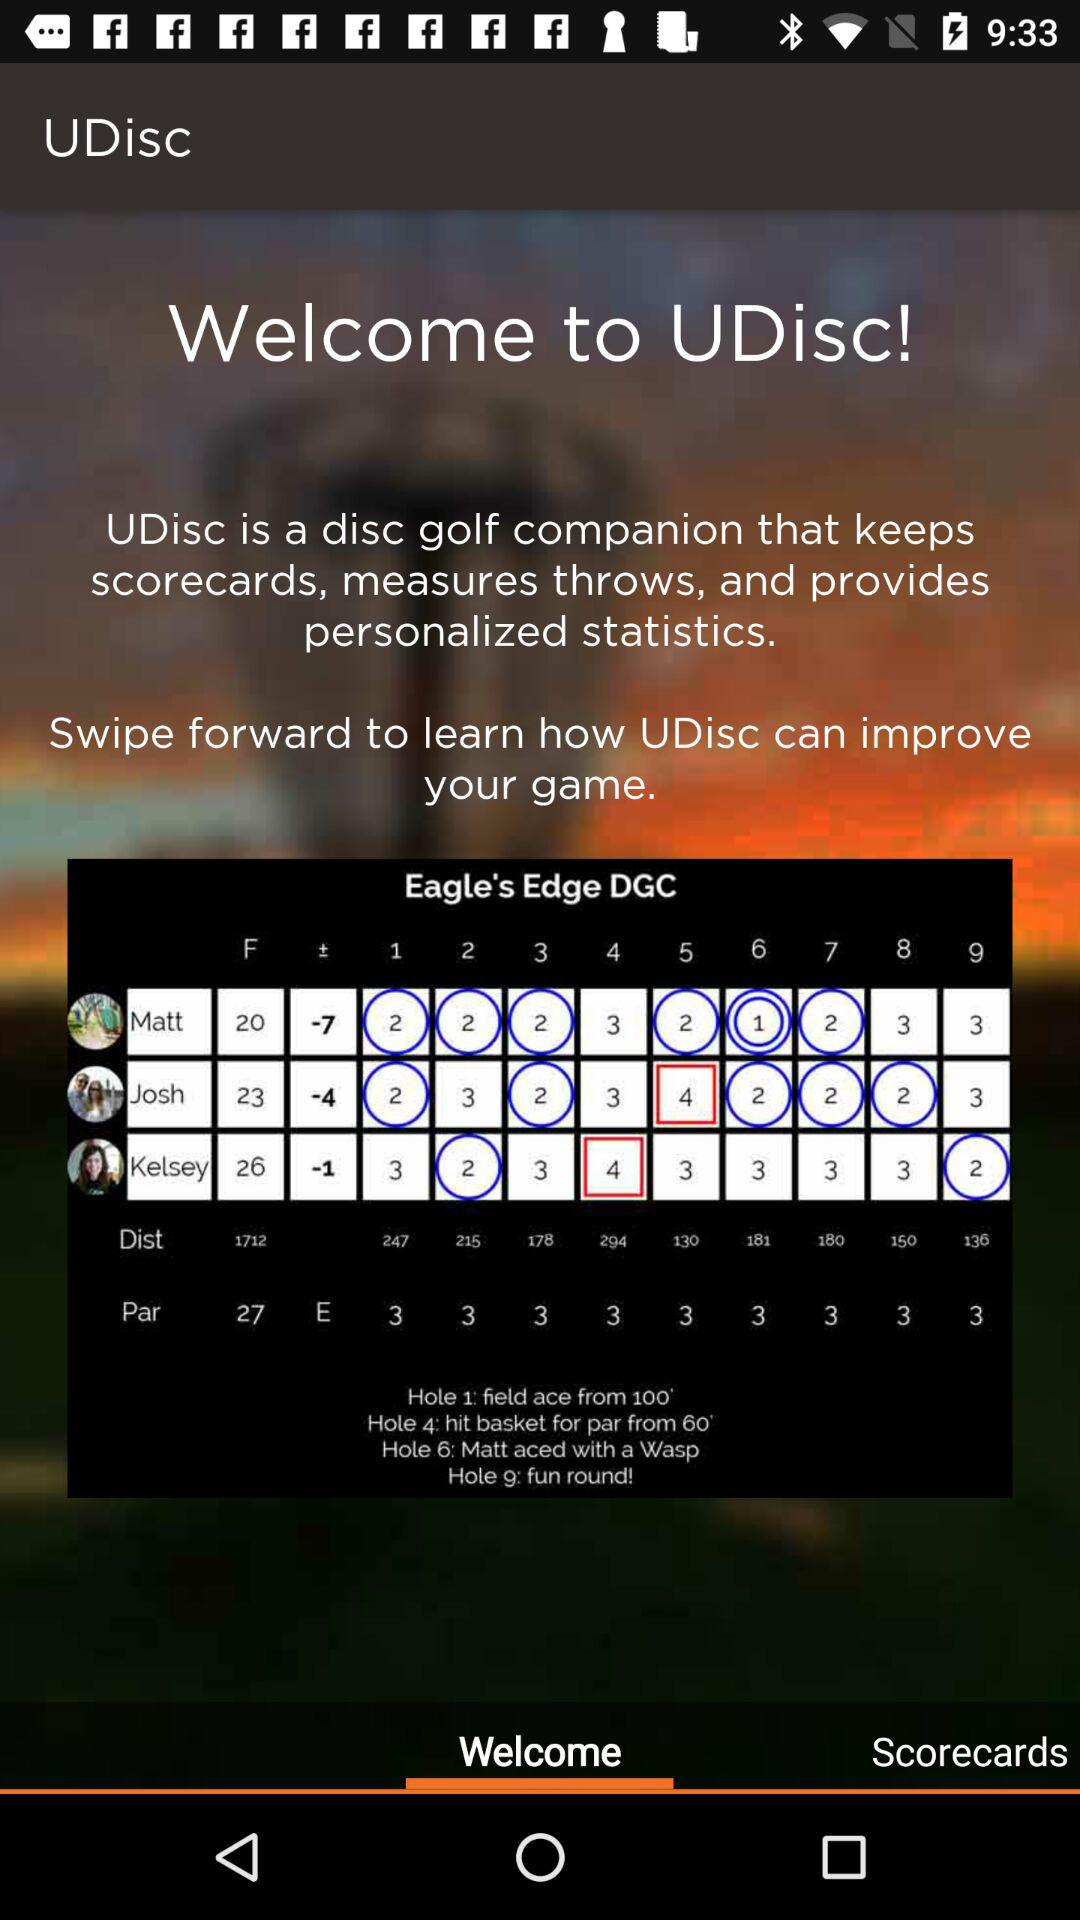Which tab is selected? The selected tab is "Welcome". 